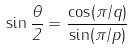Convert formula to latex. <formula><loc_0><loc_0><loc_500><loc_500>\sin \frac { \theta } { 2 } = \frac { \cos ( \pi / q ) } { \sin ( \pi / p ) }</formula> 